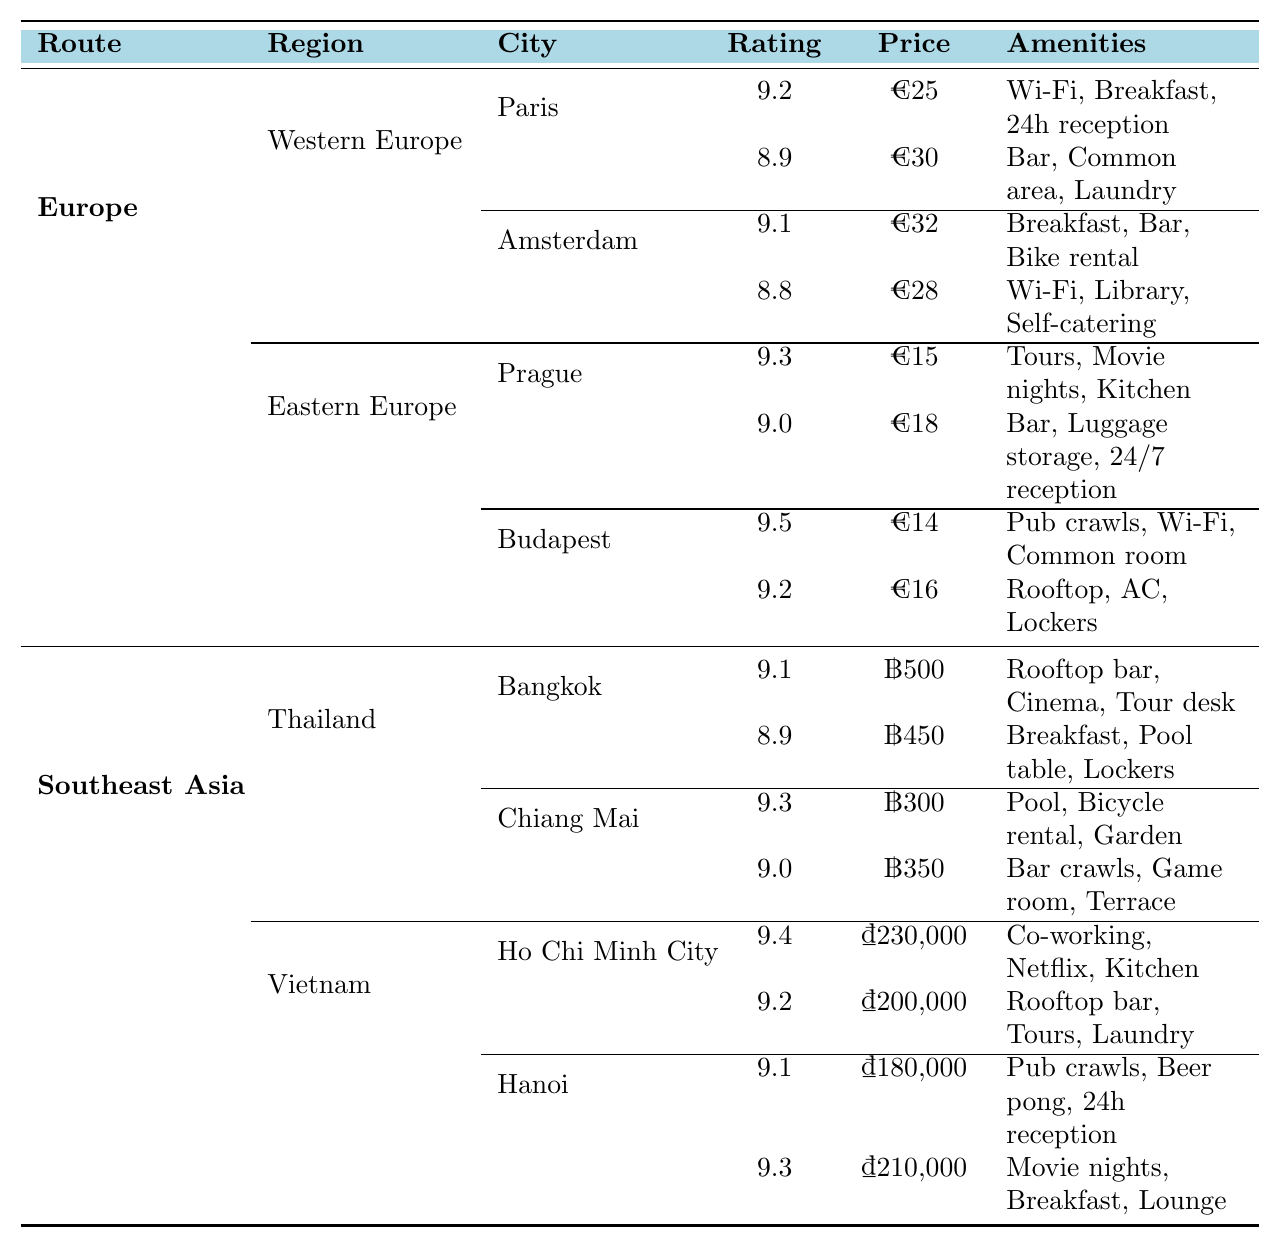What is the highest-rated hostel in Budapest? The table shows the hostels in Budapest, with "Carpe Noctem Vitae" having the highest rating of 9.5.
Answer: Carpe Noctem Vitae How much does it cost per night to stay at "Sophie's Hostel" in Prague? The table indicates that "Sophie's Hostel" costs €15 per night.
Answer: €15 Which city has the cheapest accommodation in Europe? By comparing the prices in Europe, "Carpe Noctem Vitae" in Budapest has the cheapest price at €14.
Answer: €14 Is there an accommodation in Ho Chi Minh City that offers a cinema room? Referring to the table, "Lub d Bangkok Silom" does not appear in Ho Chi Minh City but "The Common Room Project" offers a co-working space. Thus, there is no accommodation listed with a cinema room there.
Answer: No What is the average rating of the hostels in Western Europe? The ratings for Western Europe hostels are 9.2, 8.9 (Paris) and 9.1, 8.8 (Amsterdam). The average is calculated as (9.2 + 8.9 + 9.1 + 8.8) / 4 = 8.75.
Answer: 8.75 How many amenities does the "Flying Pig Downtown" offer? The table lists "Flying Pig Downtown" with three amenities: Free breakfast, Bar, and Bike rental.
Answer: 3 Which hostel in Chiang Mai has the highest rating and what is it? "Stamps Backpackers" has a rating of 9.3, which is the highest rating in Chiang Mai compared to "Bodega Chiang Mai" with a rating of 9.0.
Answer: 9.3 Does "Generator Paris" include breakfast? The amenities listed for "Generator Paris" do not include breakfast; it has a Bar, Common area, and Laundry facilities.
Answer: No Which region offers the most hostels according to the table? By counting the listed hostels, both Western and Eastern Europe have four each, while Southeast Asia has eight across its regions. Therefore, Southeast Asia offers the most.
Answer: Southeast Asia If I want to stay in a hostel that includes lockers, which places can I consider? The table lists "Maverick City Lodge" in Budapest, "Nappark Hostel" in Bangkok, and "Hideout Hostel" in Ho Chi Minh City as hostels offering lockers.
Answer: 3 hostels (Maverick City Lodge, Nappark Hostel, Hideout Hostel) 